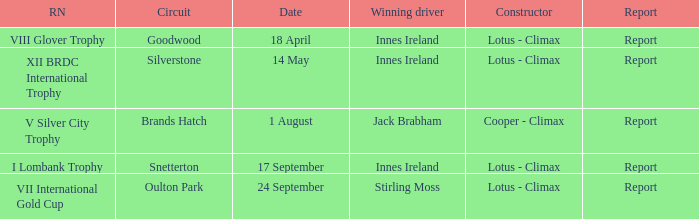What circuit did Innes Ireland win at for the I lombank trophy? Snetterton. 